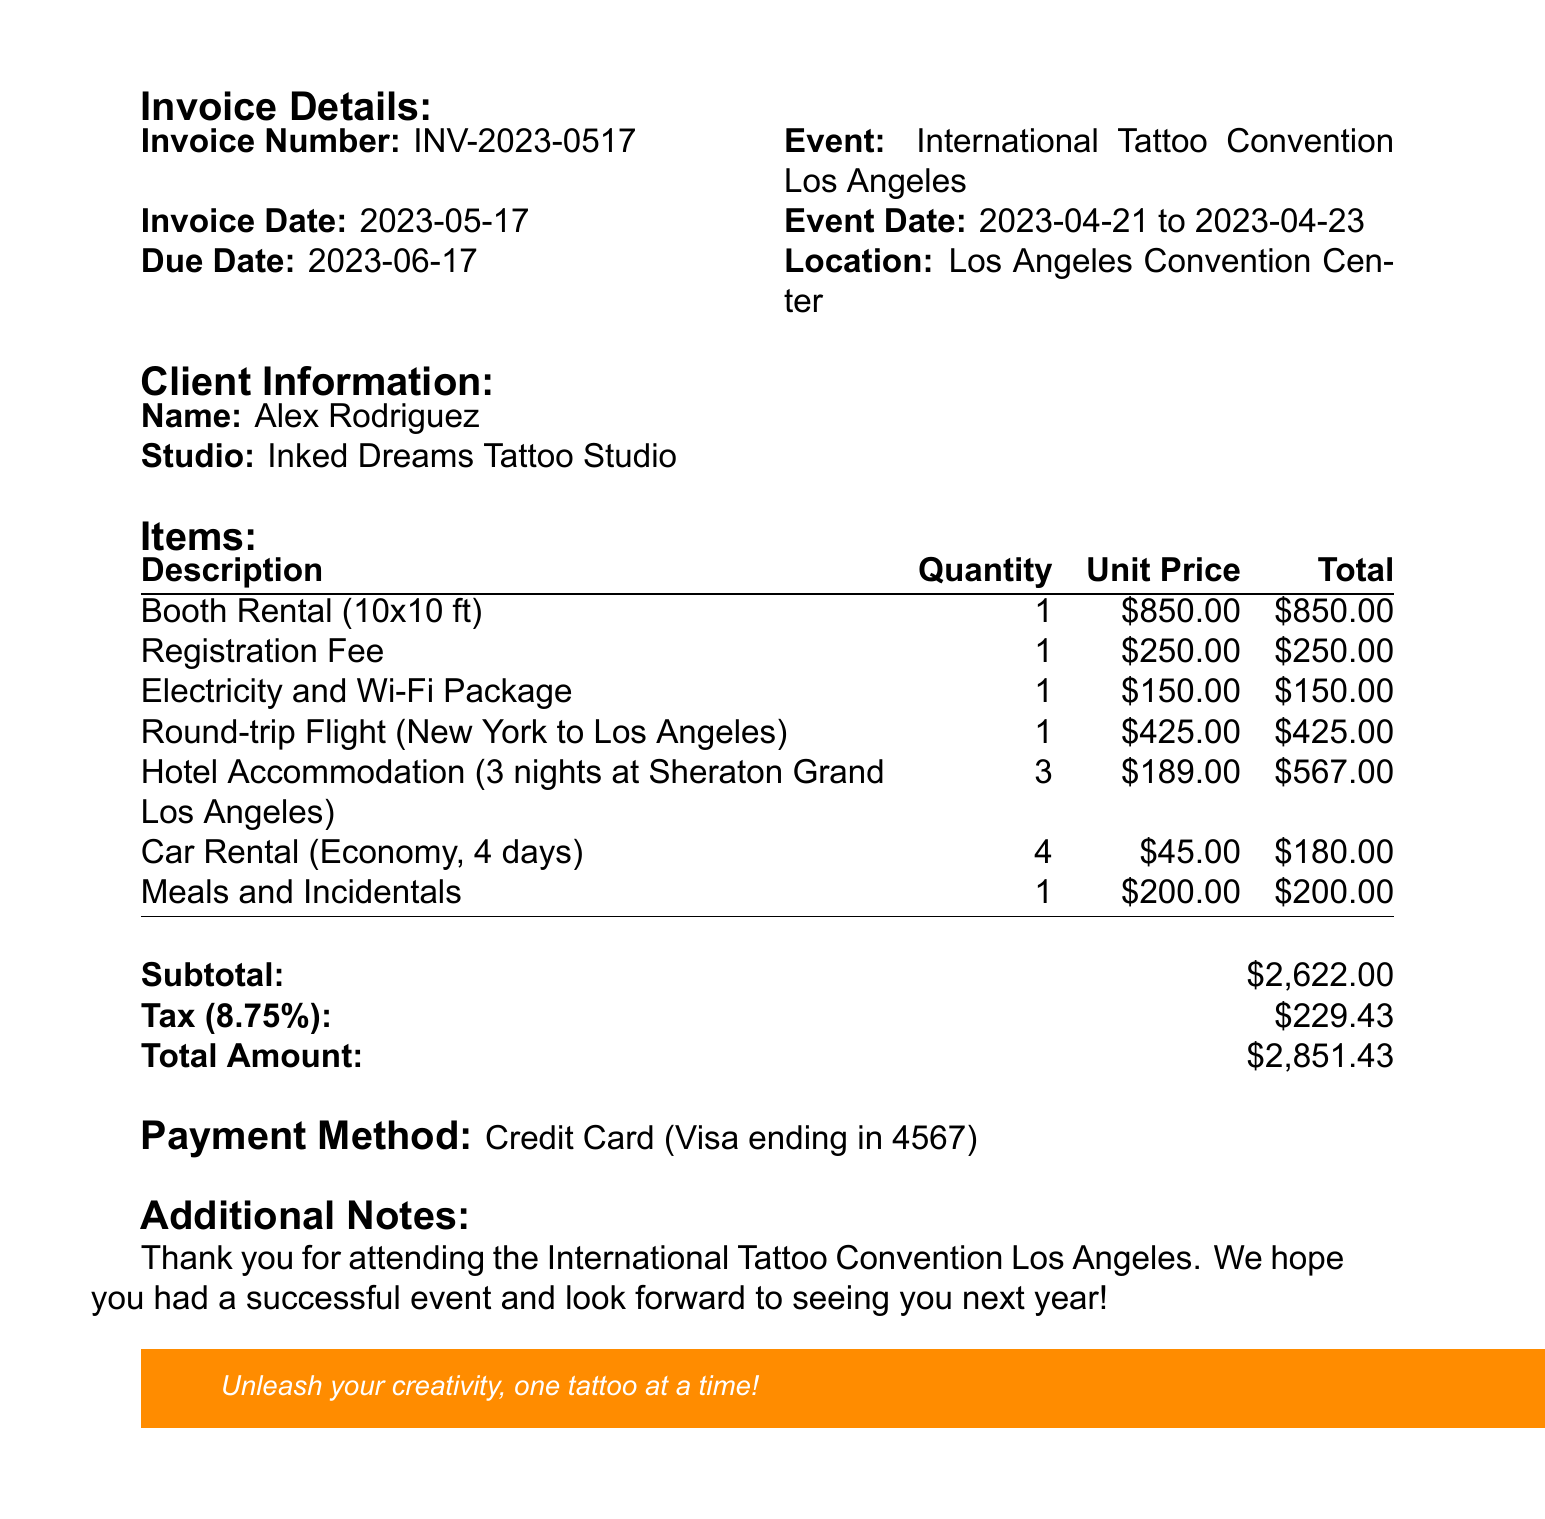What is the invoice number? The invoice number is clearly listed at the top of the document.
Answer: INV-2023-0517 What is the total amount due? The total amount appears in the summary section of the invoice.
Answer: $2,851.43 What is the date of the event? The event date is mentioned in the relevant section of the document.
Answer: 2023-04-21 to 2023-04-23 Who is the client? The client's name is specified in the client information section.
Answer: Alex Rodriguez What is the description of the first item? The first item is listed with its description at the beginning of the items section.
Answer: Booth Rental (10x10 ft) How much was spent on hotel accommodation? The total price for hotel accommodation is shown with other item totals.
Answer: $567.00 What payment method was used? The payment method is mentioned towards the end of the invoice.
Answer: Credit Card (Visa ending in 4567) What is the tax rate applied? The tax rate is provided in the summary section of the document.
Answer: 8.75% How many nights does the hotel accommodation cover? The quantity for hotel accommodation is specified in the items section.
Answer: 3 nights 